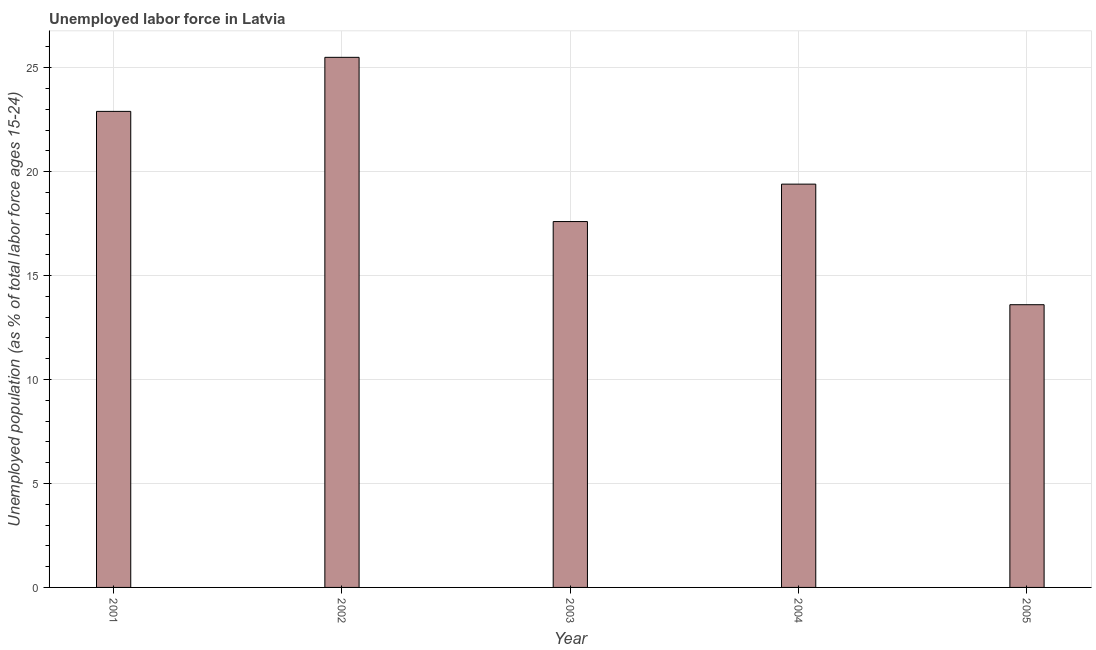What is the title of the graph?
Keep it short and to the point. Unemployed labor force in Latvia. What is the label or title of the Y-axis?
Give a very brief answer. Unemployed population (as % of total labor force ages 15-24). Across all years, what is the minimum total unemployed youth population?
Make the answer very short. 13.6. In which year was the total unemployed youth population maximum?
Your response must be concise. 2002. What is the sum of the total unemployed youth population?
Make the answer very short. 99. What is the average total unemployed youth population per year?
Ensure brevity in your answer.  19.8. What is the median total unemployed youth population?
Provide a succinct answer. 19.4. In how many years, is the total unemployed youth population greater than 10 %?
Your answer should be compact. 5. What is the ratio of the total unemployed youth population in 2001 to that in 2003?
Your response must be concise. 1.3. In how many years, is the total unemployed youth population greater than the average total unemployed youth population taken over all years?
Ensure brevity in your answer.  2. What is the Unemployed population (as % of total labor force ages 15-24) in 2001?
Ensure brevity in your answer.  22.9. What is the Unemployed population (as % of total labor force ages 15-24) of 2002?
Make the answer very short. 25.5. What is the Unemployed population (as % of total labor force ages 15-24) of 2003?
Make the answer very short. 17.6. What is the Unemployed population (as % of total labor force ages 15-24) of 2004?
Ensure brevity in your answer.  19.4. What is the Unemployed population (as % of total labor force ages 15-24) of 2005?
Keep it short and to the point. 13.6. What is the difference between the Unemployed population (as % of total labor force ages 15-24) in 2001 and 2002?
Offer a very short reply. -2.6. What is the difference between the Unemployed population (as % of total labor force ages 15-24) in 2001 and 2005?
Your response must be concise. 9.3. What is the difference between the Unemployed population (as % of total labor force ages 15-24) in 2002 and 2005?
Make the answer very short. 11.9. What is the difference between the Unemployed population (as % of total labor force ages 15-24) in 2003 and 2005?
Your response must be concise. 4. What is the ratio of the Unemployed population (as % of total labor force ages 15-24) in 2001 to that in 2002?
Keep it short and to the point. 0.9. What is the ratio of the Unemployed population (as % of total labor force ages 15-24) in 2001 to that in 2003?
Offer a very short reply. 1.3. What is the ratio of the Unemployed population (as % of total labor force ages 15-24) in 2001 to that in 2004?
Your answer should be compact. 1.18. What is the ratio of the Unemployed population (as % of total labor force ages 15-24) in 2001 to that in 2005?
Provide a short and direct response. 1.68. What is the ratio of the Unemployed population (as % of total labor force ages 15-24) in 2002 to that in 2003?
Offer a very short reply. 1.45. What is the ratio of the Unemployed population (as % of total labor force ages 15-24) in 2002 to that in 2004?
Keep it short and to the point. 1.31. What is the ratio of the Unemployed population (as % of total labor force ages 15-24) in 2002 to that in 2005?
Provide a succinct answer. 1.88. What is the ratio of the Unemployed population (as % of total labor force ages 15-24) in 2003 to that in 2004?
Ensure brevity in your answer.  0.91. What is the ratio of the Unemployed population (as % of total labor force ages 15-24) in 2003 to that in 2005?
Ensure brevity in your answer.  1.29. What is the ratio of the Unemployed population (as % of total labor force ages 15-24) in 2004 to that in 2005?
Provide a short and direct response. 1.43. 